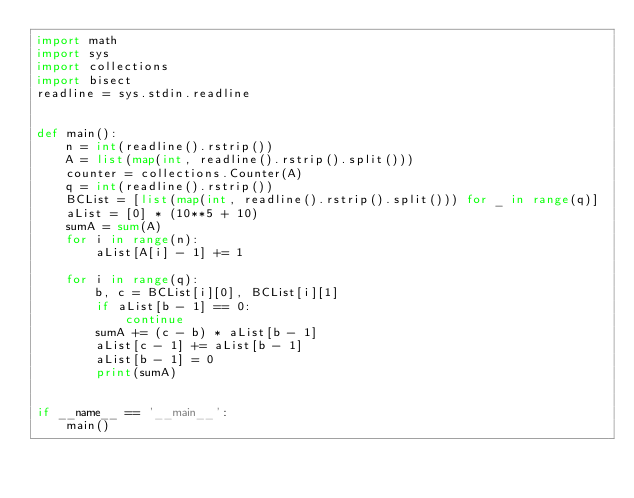Convert code to text. <code><loc_0><loc_0><loc_500><loc_500><_Python_>import math
import sys
import collections
import bisect
readline = sys.stdin.readline


def main():
    n = int(readline().rstrip())
    A = list(map(int, readline().rstrip().split()))
    counter = collections.Counter(A)
    q = int(readline().rstrip())
    BCList = [list(map(int, readline().rstrip().split())) for _ in range(q)]
    aList = [0] * (10**5 + 10)
    sumA = sum(A)
    for i in range(n):
        aList[A[i] - 1] += 1

    for i in range(q):
        b, c = BCList[i][0], BCList[i][1]
        if aList[b - 1] == 0:
            continue
        sumA += (c - b) * aList[b - 1]
        aList[c - 1] += aList[b - 1]
        aList[b - 1] = 0
        print(sumA)


if __name__ == '__main__':
    main()
</code> 